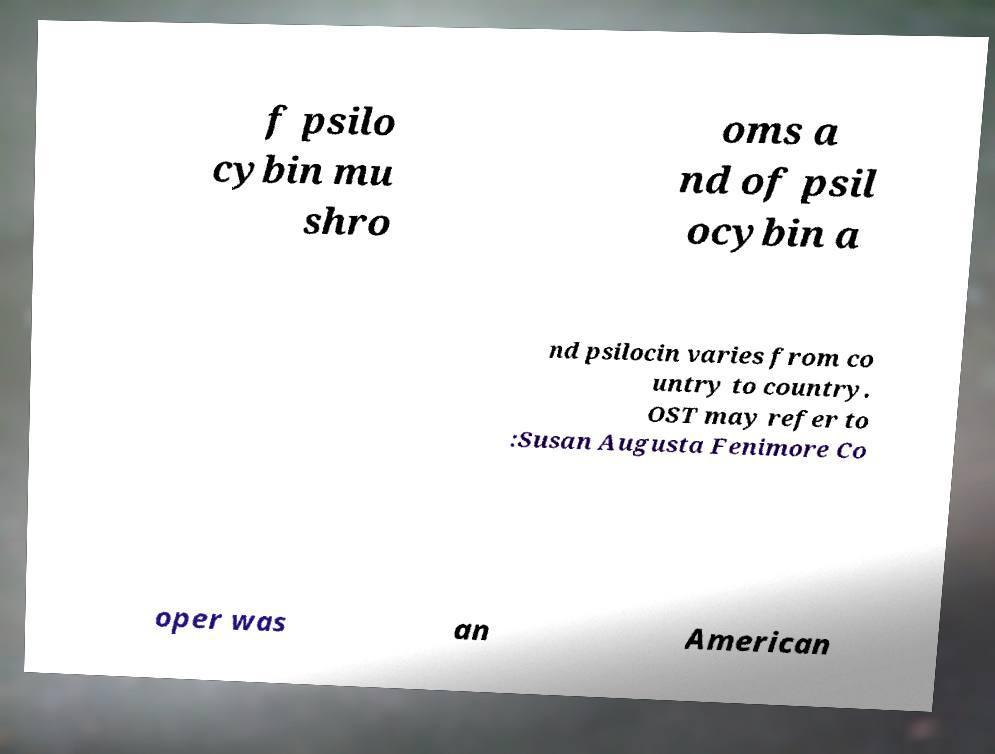For documentation purposes, I need the text within this image transcribed. Could you provide that? f psilo cybin mu shro oms a nd of psil ocybin a nd psilocin varies from co untry to country. OST may refer to :Susan Augusta Fenimore Co oper was an American 